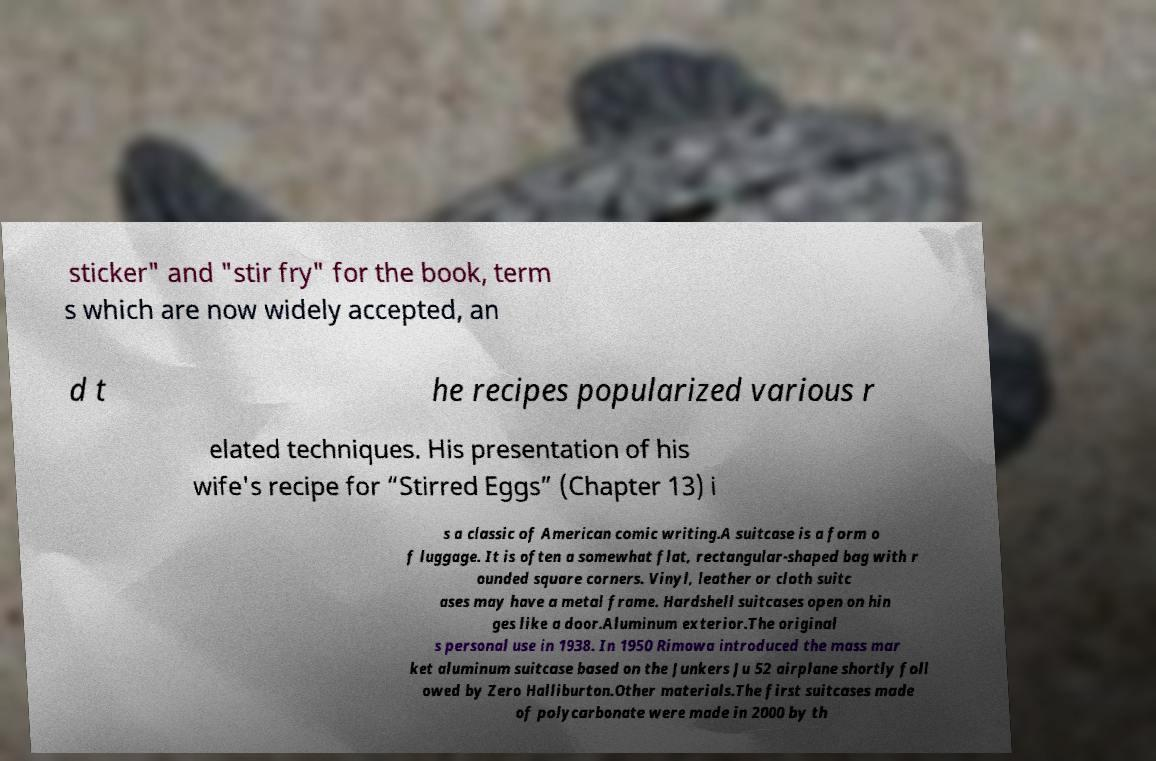Can you accurately transcribe the text from the provided image for me? sticker" and "stir fry" for the book, term s which are now widely accepted, an d t he recipes popularized various r elated techniques. His presentation of his wife's recipe for “Stirred Eggs” (Chapter 13) i s a classic of American comic writing.A suitcase is a form o f luggage. It is often a somewhat flat, rectangular-shaped bag with r ounded square corners. Vinyl, leather or cloth suitc ases may have a metal frame. Hardshell suitcases open on hin ges like a door.Aluminum exterior.The original s personal use in 1938. In 1950 Rimowa introduced the mass mar ket aluminum suitcase based on the Junkers Ju 52 airplane shortly foll owed by Zero Halliburton.Other materials.The first suitcases made of polycarbonate were made in 2000 by th 